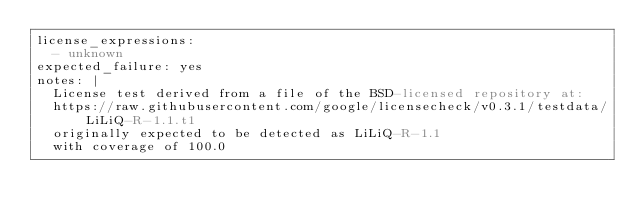<code> <loc_0><loc_0><loc_500><loc_500><_YAML_>license_expressions:
  - unknown
expected_failure: yes
notes: |
  License test derived from a file of the BSD-licensed repository at:
  https://raw.githubusercontent.com/google/licensecheck/v0.3.1/testdata/LiLiQ-R-1.1.t1
  originally expected to be detected as LiLiQ-R-1.1
  with coverage of 100.0
</code> 